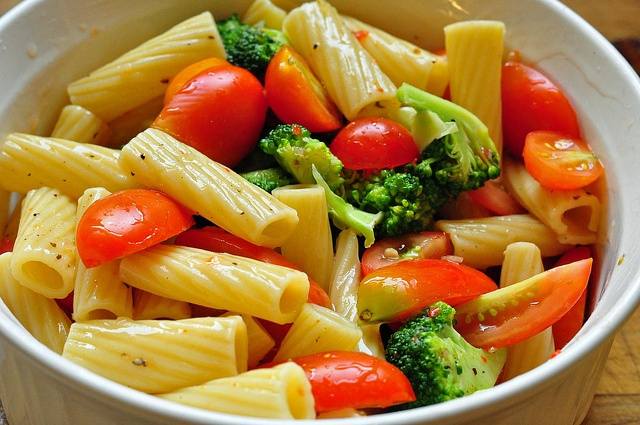Describe the objects in this image and their specific colors. I can see bowl in olive, orange, tan, and brown tones, broccoli in gray, black, olive, and darkgreen tones, dining table in gray and olive tones, broccoli in gray, black, darkgreen, and olive tones, and broccoli in gray, black, darkgreen, and green tones in this image. 